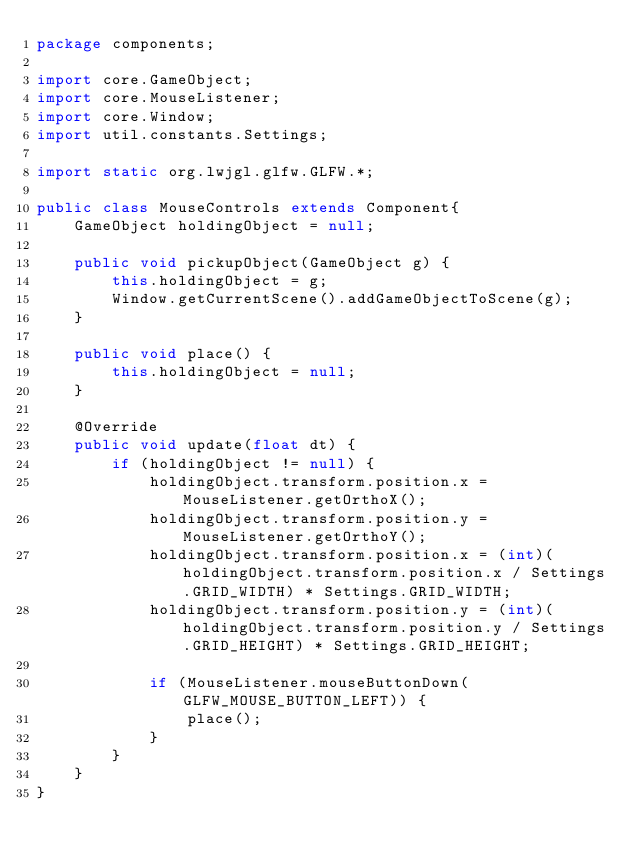<code> <loc_0><loc_0><loc_500><loc_500><_Java_>package components;

import core.GameObject;
import core.MouseListener;
import core.Window;
import util.constants.Settings;

import static org.lwjgl.glfw.GLFW.*;

public class MouseControls extends Component{
    GameObject holdingObject = null;

    public void pickupObject(GameObject g) {
        this.holdingObject = g;
        Window.getCurrentScene().addGameObjectToScene(g);
    }

    public void place() {
        this.holdingObject = null;
    }

    @Override
    public void update(float dt) {
        if (holdingObject != null) {
            holdingObject.transform.position.x = MouseListener.getOrthoX();
            holdingObject.transform.position.y = MouseListener.getOrthoY();
            holdingObject.transform.position.x = (int)(holdingObject.transform.position.x / Settings.GRID_WIDTH) * Settings.GRID_WIDTH;
            holdingObject.transform.position.y = (int)(holdingObject.transform.position.y / Settings.GRID_HEIGHT) * Settings.GRID_HEIGHT;

            if (MouseListener.mouseButtonDown(GLFW_MOUSE_BUTTON_LEFT)) {
                place();
            }
        }
    }
}
</code> 